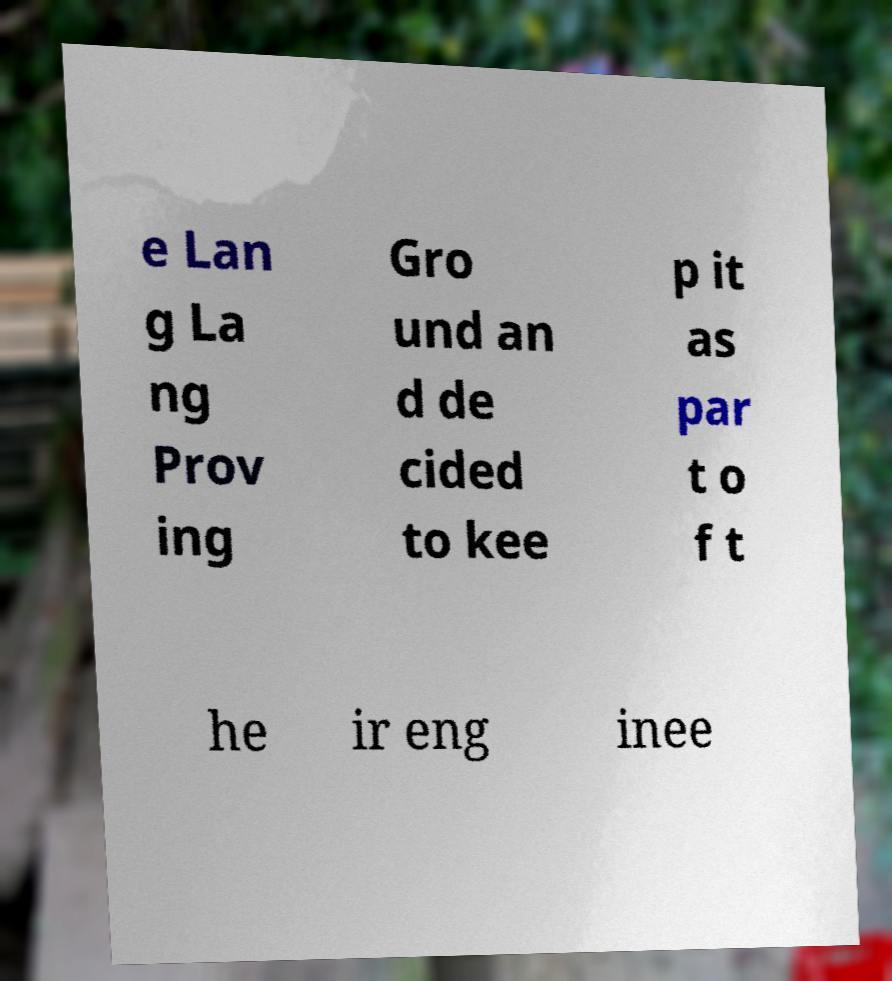Please identify and transcribe the text found in this image. e Lan g La ng Prov ing Gro und an d de cided to kee p it as par t o f t he ir eng inee 